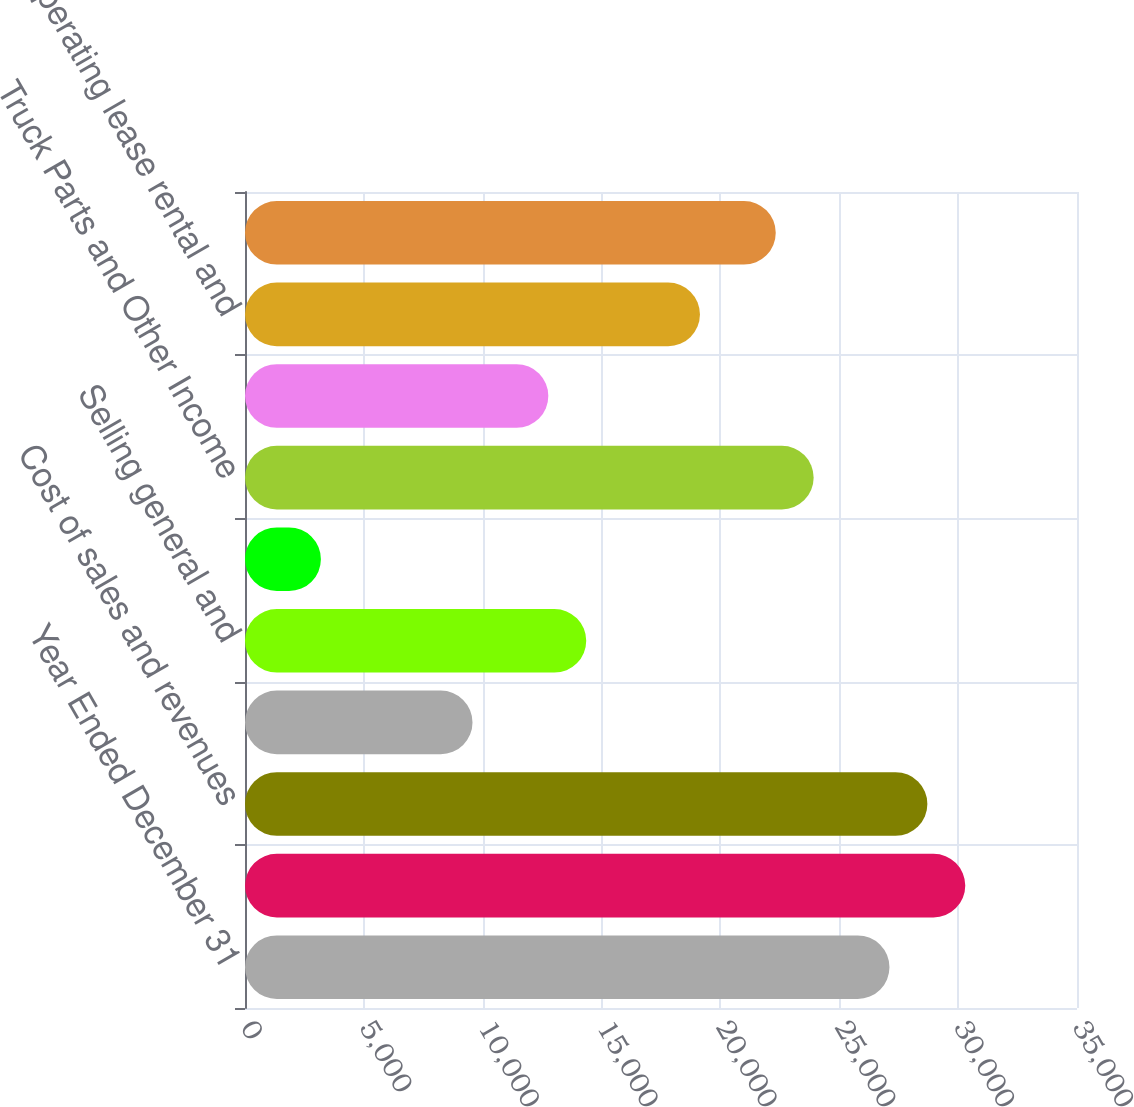<chart> <loc_0><loc_0><loc_500><loc_500><bar_chart><fcel>Year Ended December 31<fcel>Net sales and revenues<fcel>Cost of sales and revenues<fcel>Research and development<fcel>Selling general and<fcel>Interest and other expense<fcel>Truck Parts and Other Income<fcel>Interest and fees<fcel>Operating lease rental and<fcel>Revenues<nl><fcel>27110.8<fcel>30299.9<fcel>28705.4<fcel>9570.66<fcel>14354.3<fcel>3192.42<fcel>23921.7<fcel>12759.8<fcel>19138<fcel>22327.1<nl></chart> 